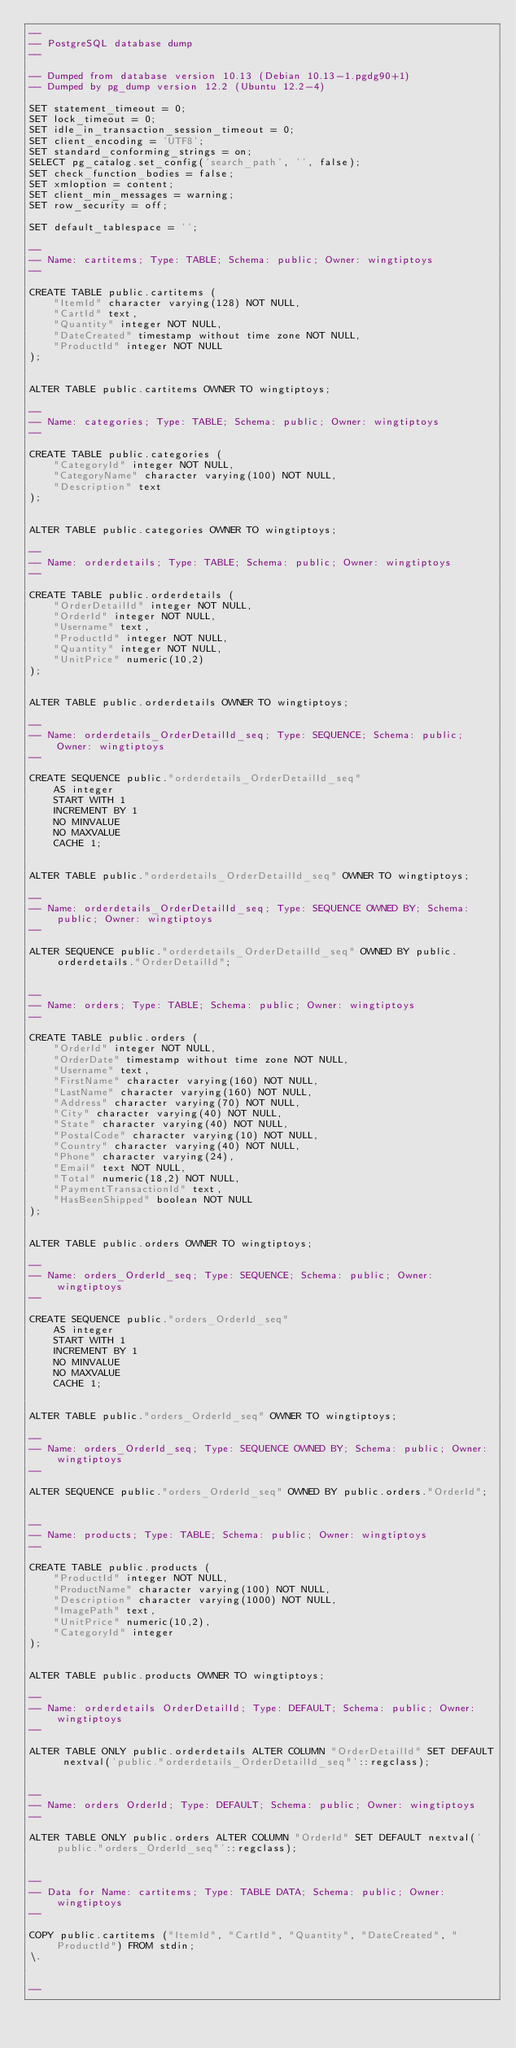Convert code to text. <code><loc_0><loc_0><loc_500><loc_500><_SQL_>--
-- PostgreSQL database dump
--

-- Dumped from database version 10.13 (Debian 10.13-1.pgdg90+1)
-- Dumped by pg_dump version 12.2 (Ubuntu 12.2-4)

SET statement_timeout = 0;
SET lock_timeout = 0;
SET idle_in_transaction_session_timeout = 0;
SET client_encoding = 'UTF8';
SET standard_conforming_strings = on;
SELECT pg_catalog.set_config('search_path', '', false);
SET check_function_bodies = false;
SET xmloption = content;
SET client_min_messages = warning;
SET row_security = off;

SET default_tablespace = '';

--
-- Name: cartitems; Type: TABLE; Schema: public; Owner: wingtiptoys
--

CREATE TABLE public.cartitems (
    "ItemId" character varying(128) NOT NULL,
    "CartId" text,
    "Quantity" integer NOT NULL,
    "DateCreated" timestamp without time zone NOT NULL,
    "ProductId" integer NOT NULL
);


ALTER TABLE public.cartitems OWNER TO wingtiptoys;

--
-- Name: categories; Type: TABLE; Schema: public; Owner: wingtiptoys
--

CREATE TABLE public.categories (
    "CategoryId" integer NOT NULL,
    "CategoryName" character varying(100) NOT NULL,
    "Description" text
);


ALTER TABLE public.categories OWNER TO wingtiptoys;

--
-- Name: orderdetails; Type: TABLE; Schema: public; Owner: wingtiptoys
--

CREATE TABLE public.orderdetails (
    "OrderDetailId" integer NOT NULL,
    "OrderId" integer NOT NULL,
    "Username" text,
    "ProductId" integer NOT NULL,
    "Quantity" integer NOT NULL,
    "UnitPrice" numeric(10,2)
);


ALTER TABLE public.orderdetails OWNER TO wingtiptoys;

--
-- Name: orderdetails_OrderDetailId_seq; Type: SEQUENCE; Schema: public; Owner: wingtiptoys
--

CREATE SEQUENCE public."orderdetails_OrderDetailId_seq"
    AS integer
    START WITH 1
    INCREMENT BY 1
    NO MINVALUE
    NO MAXVALUE
    CACHE 1;


ALTER TABLE public."orderdetails_OrderDetailId_seq" OWNER TO wingtiptoys;

--
-- Name: orderdetails_OrderDetailId_seq; Type: SEQUENCE OWNED BY; Schema: public; Owner: wingtiptoys
--

ALTER SEQUENCE public."orderdetails_OrderDetailId_seq" OWNED BY public.orderdetails."OrderDetailId";


--
-- Name: orders; Type: TABLE; Schema: public; Owner: wingtiptoys
--

CREATE TABLE public.orders (
    "OrderId" integer NOT NULL,
    "OrderDate" timestamp without time zone NOT NULL,
    "Username" text,
    "FirstName" character varying(160) NOT NULL,
    "LastName" character varying(160) NOT NULL,
    "Address" character varying(70) NOT NULL,
    "City" character varying(40) NOT NULL,
    "State" character varying(40) NOT NULL,
    "PostalCode" character varying(10) NOT NULL,
    "Country" character varying(40) NOT NULL,
    "Phone" character varying(24),
    "Email" text NOT NULL,
    "Total" numeric(18,2) NOT NULL,
    "PaymentTransactionId" text,
    "HasBeenShipped" boolean NOT NULL
);


ALTER TABLE public.orders OWNER TO wingtiptoys;

--
-- Name: orders_OrderId_seq; Type: SEQUENCE; Schema: public; Owner: wingtiptoys
--

CREATE SEQUENCE public."orders_OrderId_seq"
    AS integer
    START WITH 1
    INCREMENT BY 1
    NO MINVALUE
    NO MAXVALUE
    CACHE 1;


ALTER TABLE public."orders_OrderId_seq" OWNER TO wingtiptoys;

--
-- Name: orders_OrderId_seq; Type: SEQUENCE OWNED BY; Schema: public; Owner: wingtiptoys
--

ALTER SEQUENCE public."orders_OrderId_seq" OWNED BY public.orders."OrderId";


--
-- Name: products; Type: TABLE; Schema: public; Owner: wingtiptoys
--

CREATE TABLE public.products (
    "ProductId" integer NOT NULL,
    "ProductName" character varying(100) NOT NULL,
    "Description" character varying(1000) NOT NULL,
    "ImagePath" text,
    "UnitPrice" numeric(10,2),
    "CategoryId" integer
);


ALTER TABLE public.products OWNER TO wingtiptoys;

--
-- Name: orderdetails OrderDetailId; Type: DEFAULT; Schema: public; Owner: wingtiptoys
--

ALTER TABLE ONLY public.orderdetails ALTER COLUMN "OrderDetailId" SET DEFAULT nextval('public."orderdetails_OrderDetailId_seq"'::regclass);


--
-- Name: orders OrderId; Type: DEFAULT; Schema: public; Owner: wingtiptoys
--

ALTER TABLE ONLY public.orders ALTER COLUMN "OrderId" SET DEFAULT nextval('public."orders_OrderId_seq"'::regclass);


--
-- Data for Name: cartitems; Type: TABLE DATA; Schema: public; Owner: wingtiptoys
--

COPY public.cartitems ("ItemId", "CartId", "Quantity", "DateCreated", "ProductId") FROM stdin;
\.


--</code> 